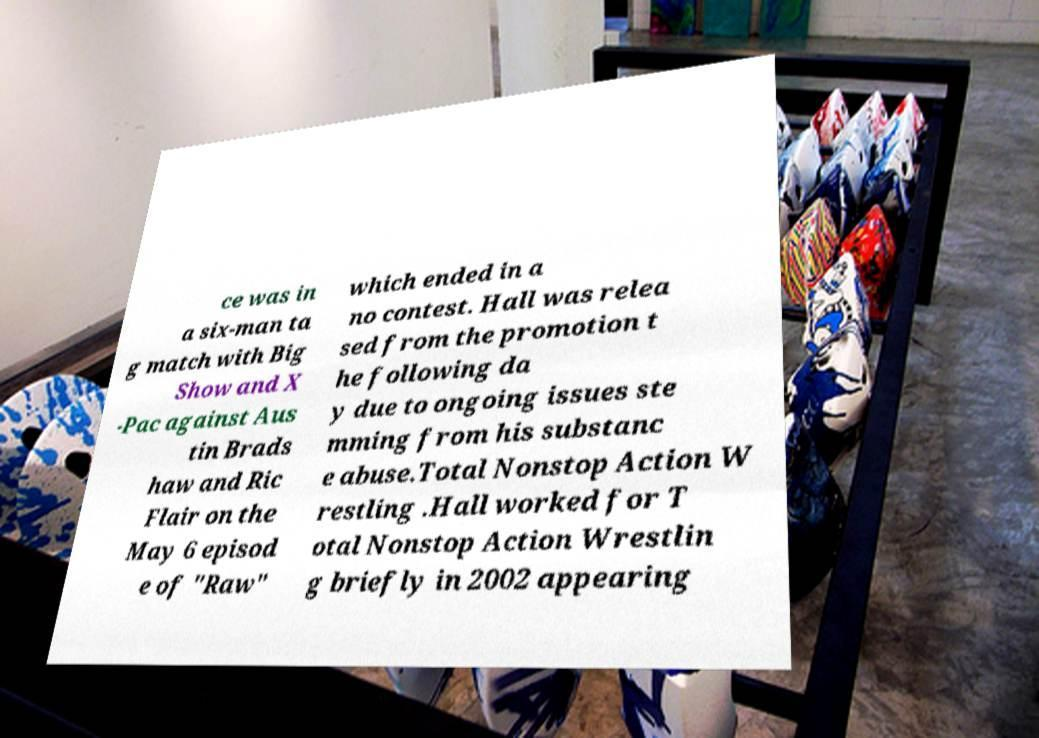Please read and relay the text visible in this image. What does it say? ce was in a six-man ta g match with Big Show and X -Pac against Aus tin Brads haw and Ric Flair on the May 6 episod e of "Raw" which ended in a no contest. Hall was relea sed from the promotion t he following da y due to ongoing issues ste mming from his substanc e abuse.Total Nonstop Action W restling .Hall worked for T otal Nonstop Action Wrestlin g briefly in 2002 appearing 